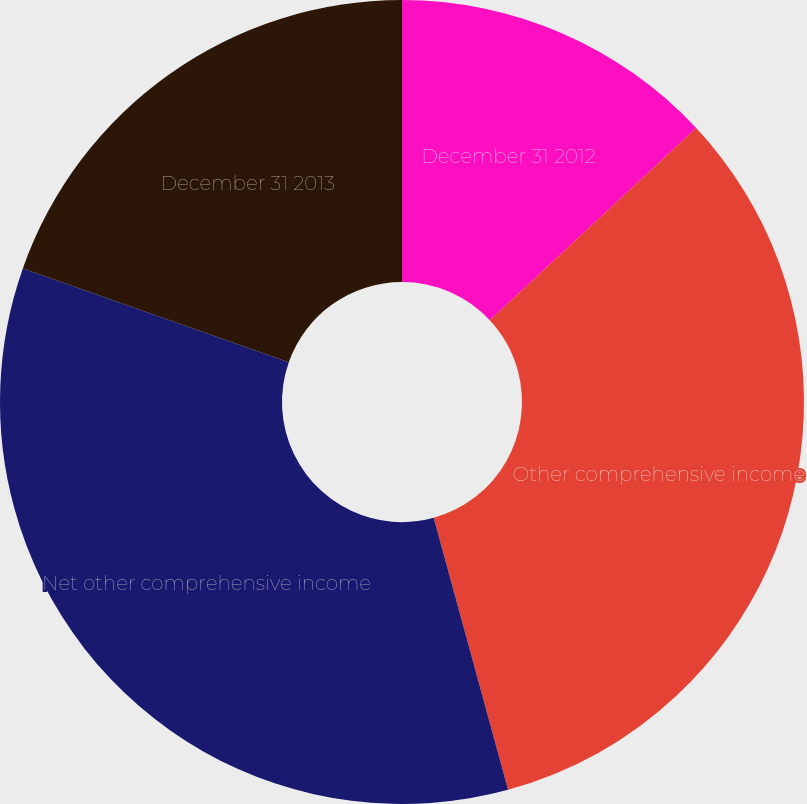Convert chart to OTSL. <chart><loc_0><loc_0><loc_500><loc_500><pie_chart><fcel>December 31 2012<fcel>Other comprehensive income<fcel>Net other comprehensive income<fcel>December 31 2013<nl><fcel>13.07%<fcel>32.68%<fcel>34.64%<fcel>19.61%<nl></chart> 